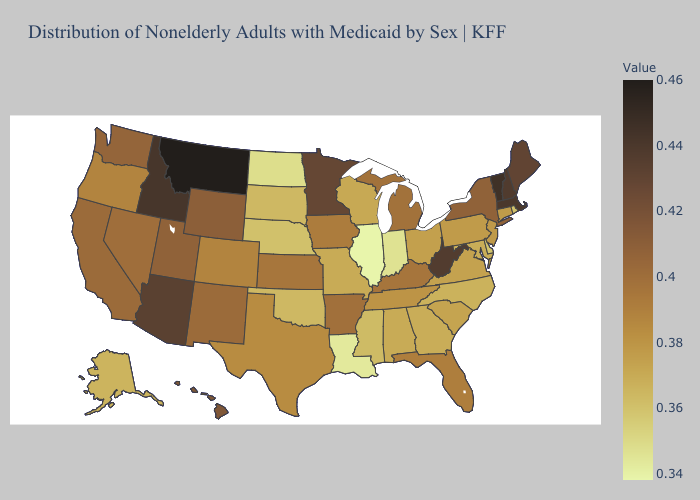Does Massachusetts have the highest value in the Northeast?
Quick response, please. No. Which states have the lowest value in the USA?
Be succinct. Illinois. Among the states that border Rhode Island , which have the highest value?
Concise answer only. Massachusetts. Among the states that border Kansas , does Colorado have the highest value?
Concise answer only. Yes. Does Missouri have the highest value in the MidWest?
Be succinct. No. Which states have the lowest value in the USA?
Be succinct. Illinois. Is the legend a continuous bar?
Give a very brief answer. Yes. 